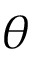Convert formula to latex. <formula><loc_0><loc_0><loc_500><loc_500>\theta</formula> 